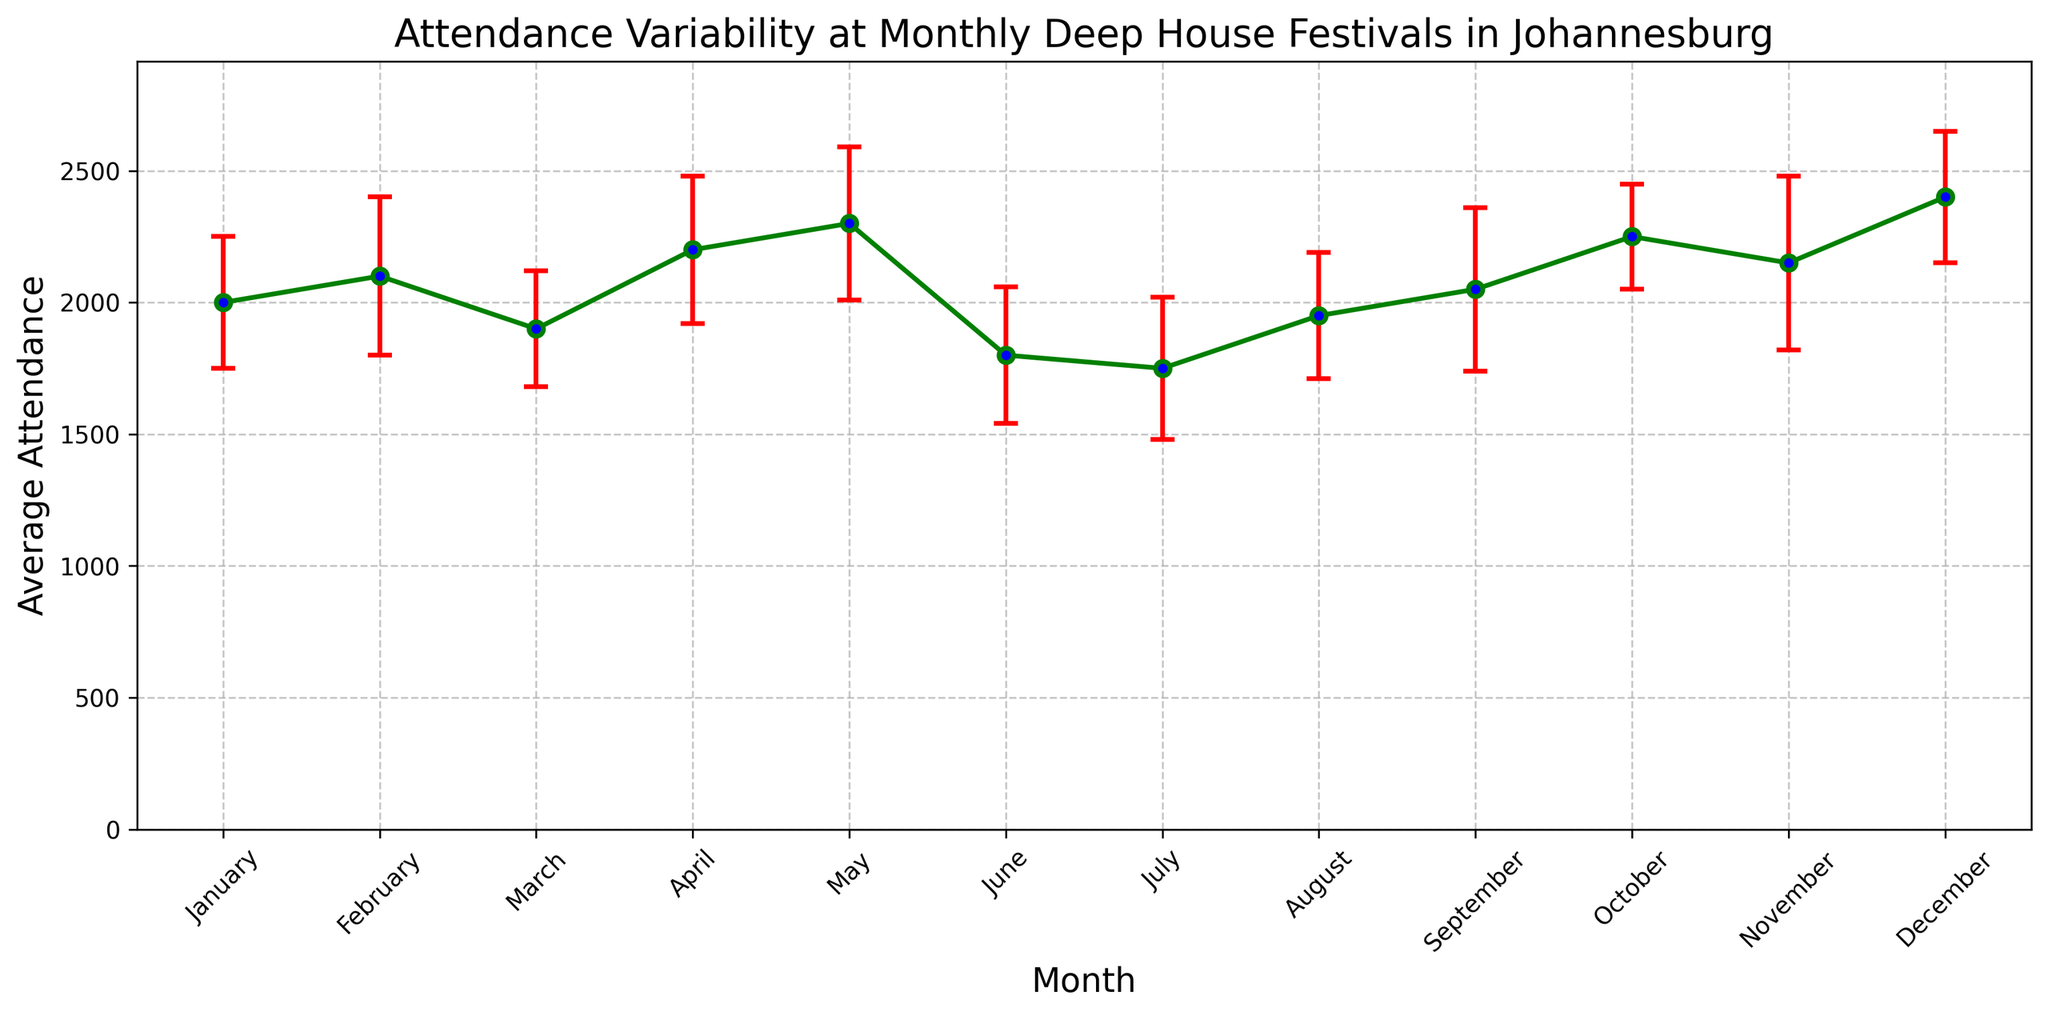Which month has the highest average attendance? Look at the plot and find the month with the tallest point indicated by the green line. December has the highest average attendance of 2400.
Answer: December Which month has the lowest average attendance? Identify the shortest green line point on the plot. July has the lowest average attendance of 1750.
Answer: July How does the average attendance in April compare to June? Compare the height of the green points corresponding to April and June. April's average attendance (2200) is higher than June's (1800).
Answer: April's is higher Which months have an average attendance above 2200? Look for points taller than the 2200 marker on the plot. May, October, and December have average attendances above 2200.
Answer: May, October, December What is the average attendance for March and how much does it differ from August? Note March and August values and calculate the difference. March's average attendance is 1900, and August's is 1950. The difference is \(1950 - 1900 = 50\).
Answer: 50 By how much does attendance in February vary? Check the error bar length in February. The standard deviation is 300, showing the variability in attendance.
Answer: 300 What is the total attendance for the first quarter (January, February, March)? Sum the attendance values for January, February, and March. \(2000 + 2100 + 1900\) is 6000.
Answer: 6000 Which month shows the highest variability in attendance? Identify the longest red error bar. November has the highest standard deviation of 330.
Answer: November Is the average attendance in January closer to that of February or March? Compare differences: \(2100 - 2000 = 100\) for February, and \(2000 - 1900 = 100\) for March. January is equally close to both February and March.
Answer: Equally close By how much does attendance increase from July to September? Calculate the change: \(2050 - 1750 = 300\). Attendance increases by 300 from July to September.
Answer: 300 